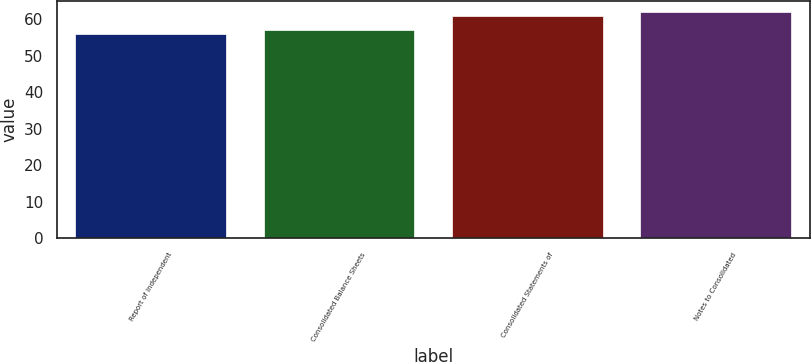<chart> <loc_0><loc_0><loc_500><loc_500><bar_chart><fcel>Report of Independent<fcel>Consolidated Balance Sheets<fcel>Consolidated Statements of<fcel>Notes to Consolidated<nl><fcel>56<fcel>57<fcel>61<fcel>62<nl></chart> 